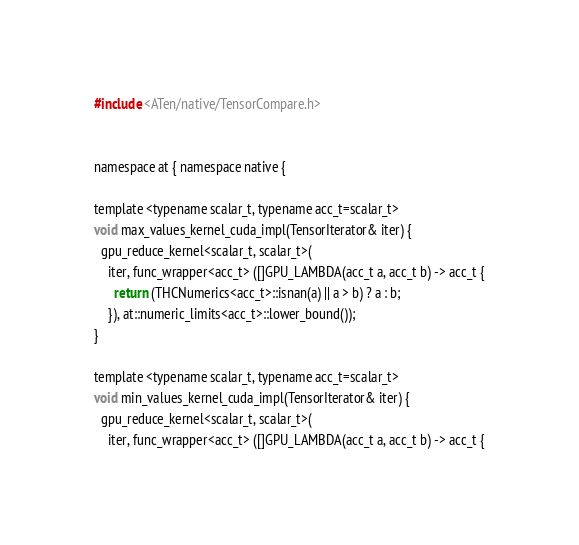Convert code to text. <code><loc_0><loc_0><loc_500><loc_500><_Cuda_>#include <ATen/native/TensorCompare.h>


namespace at { namespace native {

template <typename scalar_t, typename acc_t=scalar_t>
void max_values_kernel_cuda_impl(TensorIterator& iter) {
  gpu_reduce_kernel<scalar_t, scalar_t>(
    iter, func_wrapper<acc_t> ([]GPU_LAMBDA(acc_t a, acc_t b) -> acc_t {
      return (THCNumerics<acc_t>::isnan(a) || a > b) ? a : b;
    }), at::numeric_limits<acc_t>::lower_bound());
}

template <typename scalar_t, typename acc_t=scalar_t>
void min_values_kernel_cuda_impl(TensorIterator& iter) {
  gpu_reduce_kernel<scalar_t, scalar_t>(
    iter, func_wrapper<acc_t> ([]GPU_LAMBDA(acc_t a, acc_t b) -> acc_t {</code> 